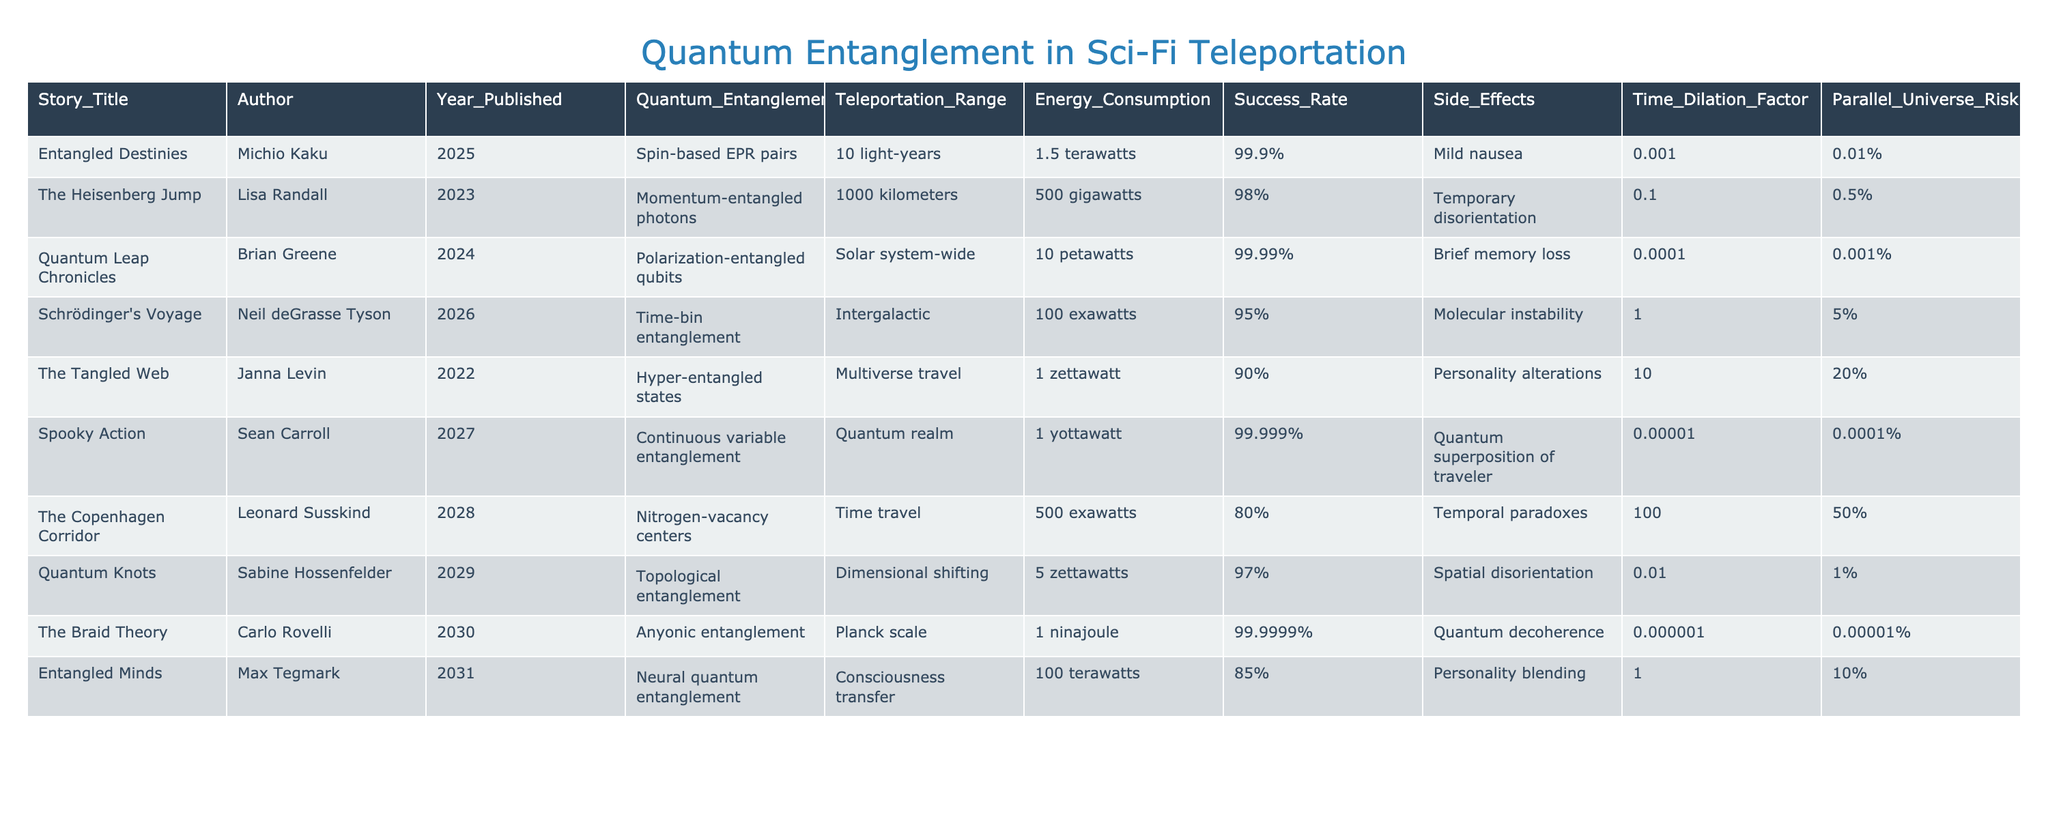What teleportation range is described in "Entangled Destinies"? The table lists "Entangled Destinies" as having a teleportation range of 10 light-years.
Answer: 10 light-years Which story has the highest success rate for teleportation? Analyzing the success rates in the table, "Quantum Leap Chronicles" has the highest success rate at 99.99%.
Answer: 99.99% What is the energy consumption required for "Schrödinger's Voyage"? The table indicates that "Schrödinger's Voyage" consumes 100 exawatts of energy for teleportation.
Answer: 100 exawatts Which method of quantum entanglement is used in "The Braid Theory"? The table states that "The Braid Theory" utilizes anyonic entanglement as its method.
Answer: Anyonic entanglement What is the average energy consumption across all stories? Calculating the average involves summing the energy consumption values (1.5 + 500 + 10 + 100 + 1 + 1 + 500 + 5 + 1 + 100) in terawatts and dividing by 10. The total sum is 1116.5 terawatts, so the average is 111.65 terawatts.
Answer: 111.65 terawatts Is there any story with a teleportation range less than 100 kilometers? Checking all teleportation ranges in the table, "Entangled Destinies" is the only story with a range less than 100 kilometers (10 light-years).
Answer: Yes How many stories have side effects classified as "Molecular instability"? Referring to the table, only "Schrödinger's Voyage" lists molecular instability as a side effect, so there is only one such story.
Answer: 1 Can we find a story with a parallel universe risk greater than 10%? The table shows that "The Tangled Web" has a parallel universe risk of 20%, which exceeds 10%.
Answer: Yes What is the difference in energy consumption between "The Tangled Web" and "Quantum Knots"? The table shows that "The Tangled Web" consumes 1 zettawatt and "Quantum Knots" consumes 5 zettawatts. The difference is 5 - 1 = 4 zettawatts.
Answer: 4 zettawatts List all stories with a teleportation range of "Solar system-wide" or greater. The table lists two stories: "Quantum Leap Chronicles" with a solar system-wide range and "Schrödinger's Voyage" with an intergalactic range.
Answer: "Quantum Leap Chronicles" and "Schrödinger's Voyage" 